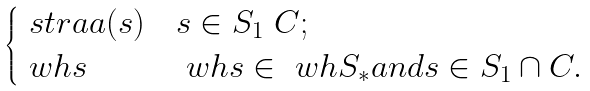Convert formula to latex. <formula><loc_0><loc_0><loc_500><loc_500>\begin{cases} \ s t r a a ( s ) & s \in S _ { 1 } \ C ; \\ \ w h { s } & \ w h { s } \in \ w h { S } _ { * } a n d s \in S _ { 1 } \cap C . \end{cases}</formula> 